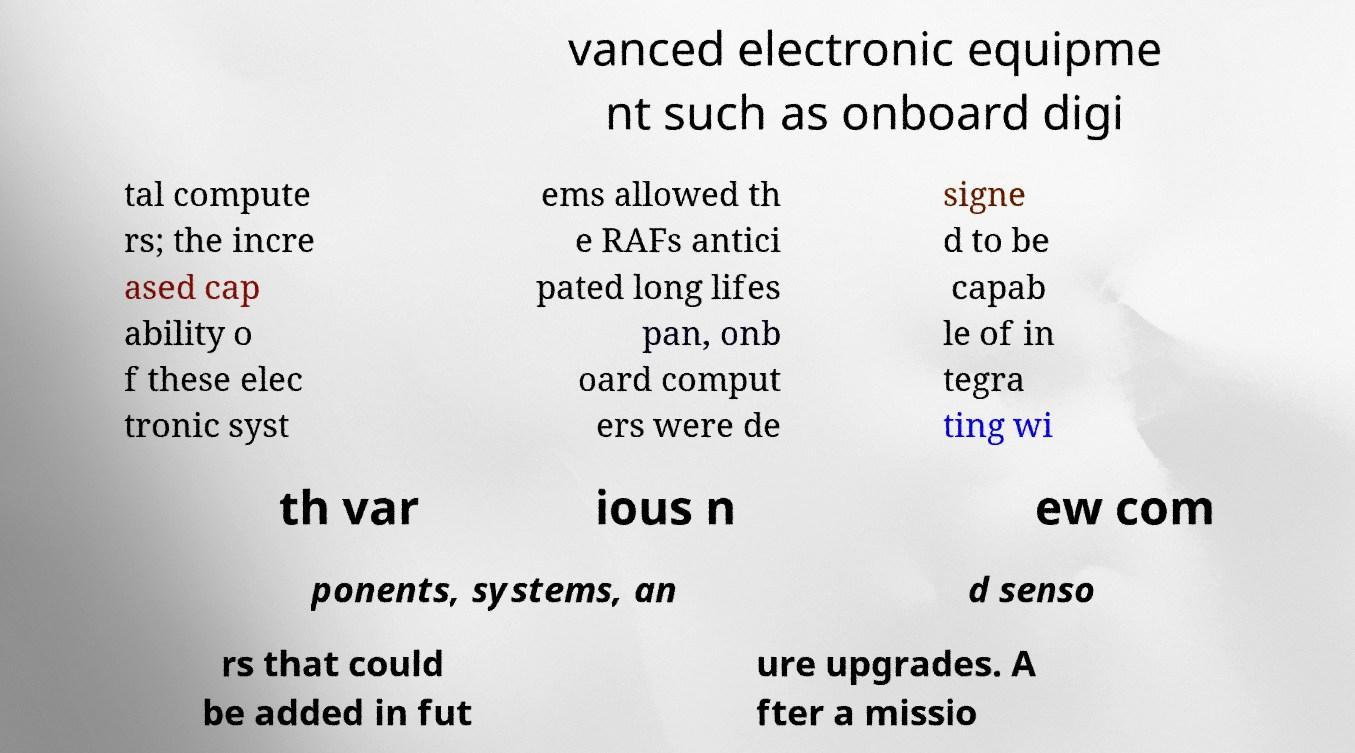Can you read and provide the text displayed in the image?This photo seems to have some interesting text. Can you extract and type it out for me? vanced electronic equipme nt such as onboard digi tal compute rs; the incre ased cap ability o f these elec tronic syst ems allowed th e RAFs antici pated long lifes pan, onb oard comput ers were de signe d to be capab le of in tegra ting wi th var ious n ew com ponents, systems, an d senso rs that could be added in fut ure upgrades. A fter a missio 